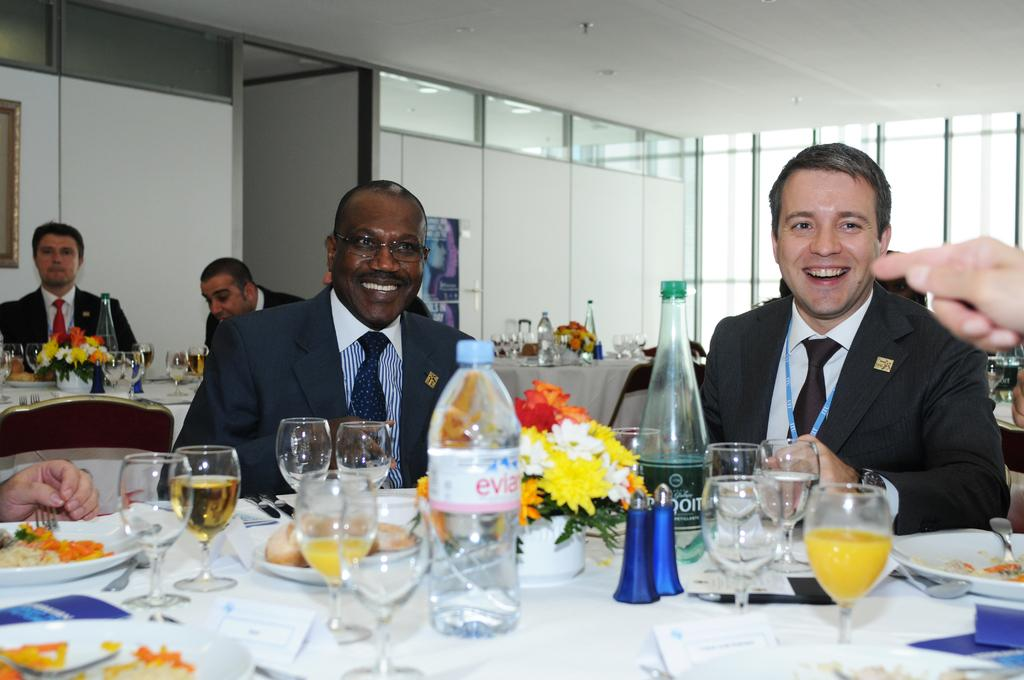What are the people in the image doing? The people in the image are sitting on chairs. What can be seen on the table in the image? There are wine glasses, a wine bottle, a water bottle, and a flower bouquet on the table. How many types of beverages are present on the table? There are two types of beverages on the table: wine and water. What type of polish is being applied to the table in the image? There is no polish being applied to the table in the image. How many clocks are visible on the table in the image? There are no clocks visible on the table in the image. 